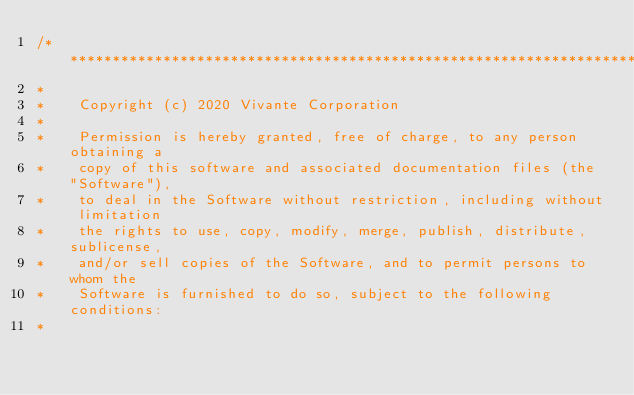Convert code to text. <code><loc_0><loc_0><loc_500><loc_500><_C_>/****************************************************************************
*
*    Copyright (c) 2020 Vivante Corporation
*
*    Permission is hereby granted, free of charge, to any person obtaining a
*    copy of this software and associated documentation files (the "Software"),
*    to deal in the Software without restriction, including without limitation
*    the rights to use, copy, modify, merge, publish, distribute, sublicense,
*    and/or sell copies of the Software, and to permit persons to whom the
*    Software is furnished to do so, subject to the following conditions:
*</code> 